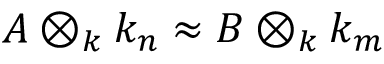<formula> <loc_0><loc_0><loc_500><loc_500>A \otimes _ { k } k _ { n } \approx B \otimes _ { k } k _ { m }</formula> 